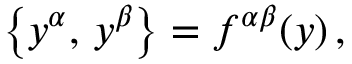<formula> <loc_0><loc_0><loc_500><loc_500>\left \{ y ^ { \alpha } , \, y ^ { \beta } \right \} = f ^ { \alpha \beta } ( y ) \, ,</formula> 